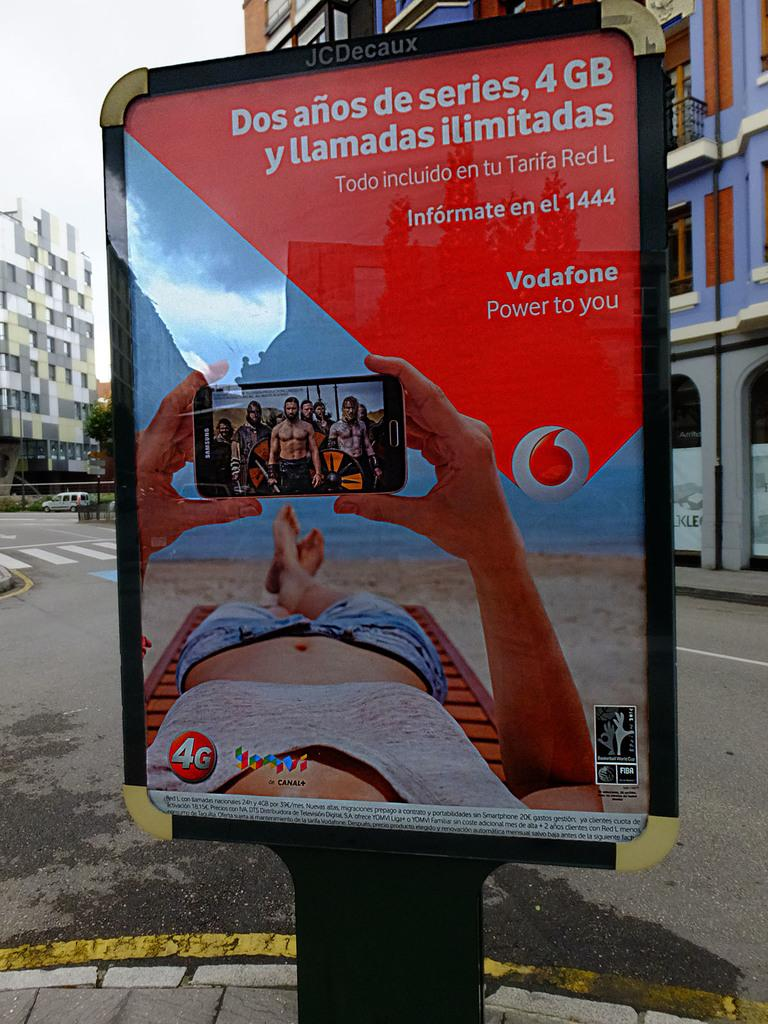<image>
Write a terse but informative summary of the picture. A Spanish advertisement for smart phones that says 4 GB at the top. 